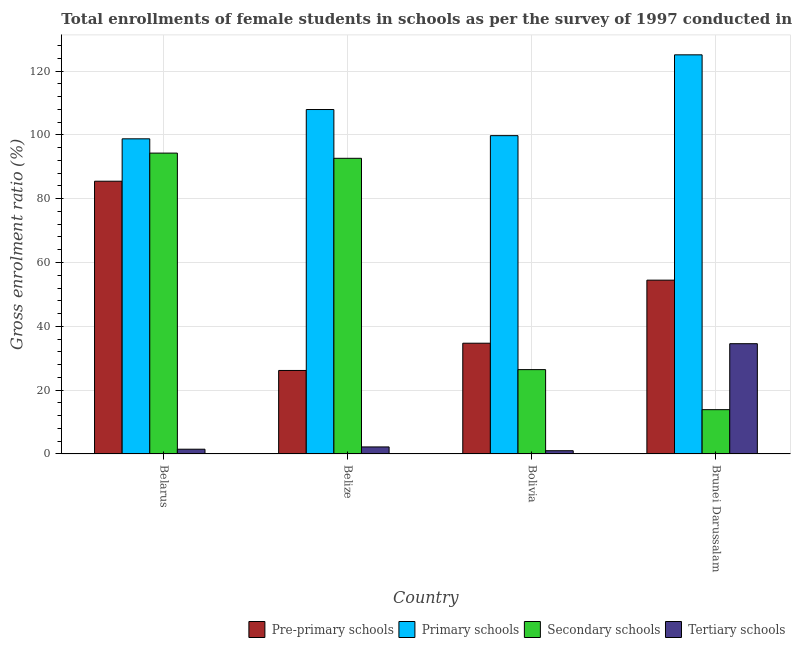How many groups of bars are there?
Give a very brief answer. 4. Are the number of bars per tick equal to the number of legend labels?
Provide a succinct answer. Yes. How many bars are there on the 4th tick from the left?
Offer a very short reply. 4. How many bars are there on the 4th tick from the right?
Give a very brief answer. 4. What is the label of the 2nd group of bars from the left?
Provide a succinct answer. Belize. What is the gross enrolment ratio(female) in primary schools in Belarus?
Offer a very short reply. 98.76. Across all countries, what is the maximum gross enrolment ratio(female) in tertiary schools?
Offer a very short reply. 34.56. Across all countries, what is the minimum gross enrolment ratio(female) in secondary schools?
Ensure brevity in your answer.  13.88. In which country was the gross enrolment ratio(female) in pre-primary schools maximum?
Offer a very short reply. Belarus. In which country was the gross enrolment ratio(female) in pre-primary schools minimum?
Your answer should be very brief. Belize. What is the total gross enrolment ratio(female) in pre-primary schools in the graph?
Make the answer very short. 200.83. What is the difference between the gross enrolment ratio(female) in pre-primary schools in Belize and that in Bolivia?
Give a very brief answer. -8.54. What is the difference between the gross enrolment ratio(female) in tertiary schools in Bolivia and the gross enrolment ratio(female) in primary schools in Belarus?
Offer a terse response. -97.74. What is the average gross enrolment ratio(female) in tertiary schools per country?
Your answer should be very brief. 9.82. What is the difference between the gross enrolment ratio(female) in primary schools and gross enrolment ratio(female) in secondary schools in Brunei Darussalam?
Keep it short and to the point. 111.19. In how many countries, is the gross enrolment ratio(female) in secondary schools greater than 48 %?
Provide a short and direct response. 2. What is the ratio of the gross enrolment ratio(female) in tertiary schools in Bolivia to that in Brunei Darussalam?
Make the answer very short. 0.03. Is the gross enrolment ratio(female) in primary schools in Belarus less than that in Belize?
Make the answer very short. Yes. What is the difference between the highest and the second highest gross enrolment ratio(female) in secondary schools?
Your answer should be compact. 1.63. What is the difference between the highest and the lowest gross enrolment ratio(female) in secondary schools?
Offer a terse response. 80.4. Is the sum of the gross enrolment ratio(female) in secondary schools in Belarus and Belize greater than the maximum gross enrolment ratio(female) in tertiary schools across all countries?
Provide a succinct answer. Yes. What does the 4th bar from the left in Brunei Darussalam represents?
Your answer should be very brief. Tertiary schools. What does the 3rd bar from the right in Belize represents?
Provide a succinct answer. Primary schools. Is it the case that in every country, the sum of the gross enrolment ratio(female) in pre-primary schools and gross enrolment ratio(female) in primary schools is greater than the gross enrolment ratio(female) in secondary schools?
Give a very brief answer. Yes. Are all the bars in the graph horizontal?
Your response must be concise. No. How many countries are there in the graph?
Your response must be concise. 4. What is the difference between two consecutive major ticks on the Y-axis?
Keep it short and to the point. 20. Does the graph contain any zero values?
Keep it short and to the point. No. How many legend labels are there?
Make the answer very short. 4. How are the legend labels stacked?
Your answer should be very brief. Horizontal. What is the title of the graph?
Make the answer very short. Total enrollments of female students in schools as per the survey of 1997 conducted in different countries. Does "Minerals" appear as one of the legend labels in the graph?
Provide a short and direct response. No. What is the label or title of the X-axis?
Your response must be concise. Country. What is the Gross enrolment ratio (%) in Pre-primary schools in Belarus?
Make the answer very short. 85.48. What is the Gross enrolment ratio (%) of Primary schools in Belarus?
Provide a short and direct response. 98.76. What is the Gross enrolment ratio (%) in Secondary schools in Belarus?
Your answer should be compact. 94.28. What is the Gross enrolment ratio (%) in Tertiary schools in Belarus?
Keep it short and to the point. 1.49. What is the Gross enrolment ratio (%) of Pre-primary schools in Belize?
Provide a short and direct response. 26.17. What is the Gross enrolment ratio (%) in Primary schools in Belize?
Ensure brevity in your answer.  107.94. What is the Gross enrolment ratio (%) of Secondary schools in Belize?
Give a very brief answer. 92.65. What is the Gross enrolment ratio (%) in Tertiary schools in Belize?
Give a very brief answer. 2.2. What is the Gross enrolment ratio (%) in Pre-primary schools in Bolivia?
Offer a terse response. 34.71. What is the Gross enrolment ratio (%) of Primary schools in Bolivia?
Offer a terse response. 99.75. What is the Gross enrolment ratio (%) of Secondary schools in Bolivia?
Your answer should be very brief. 26.43. What is the Gross enrolment ratio (%) in Tertiary schools in Bolivia?
Provide a succinct answer. 1.02. What is the Gross enrolment ratio (%) in Pre-primary schools in Brunei Darussalam?
Ensure brevity in your answer.  54.47. What is the Gross enrolment ratio (%) in Primary schools in Brunei Darussalam?
Provide a succinct answer. 125.08. What is the Gross enrolment ratio (%) of Secondary schools in Brunei Darussalam?
Make the answer very short. 13.88. What is the Gross enrolment ratio (%) of Tertiary schools in Brunei Darussalam?
Your response must be concise. 34.56. Across all countries, what is the maximum Gross enrolment ratio (%) in Pre-primary schools?
Your answer should be compact. 85.48. Across all countries, what is the maximum Gross enrolment ratio (%) of Primary schools?
Your response must be concise. 125.08. Across all countries, what is the maximum Gross enrolment ratio (%) of Secondary schools?
Your answer should be compact. 94.28. Across all countries, what is the maximum Gross enrolment ratio (%) in Tertiary schools?
Provide a short and direct response. 34.56. Across all countries, what is the minimum Gross enrolment ratio (%) of Pre-primary schools?
Your answer should be compact. 26.17. Across all countries, what is the minimum Gross enrolment ratio (%) of Primary schools?
Keep it short and to the point. 98.76. Across all countries, what is the minimum Gross enrolment ratio (%) of Secondary schools?
Your answer should be compact. 13.88. Across all countries, what is the minimum Gross enrolment ratio (%) of Tertiary schools?
Offer a very short reply. 1.02. What is the total Gross enrolment ratio (%) in Pre-primary schools in the graph?
Your answer should be very brief. 200.83. What is the total Gross enrolment ratio (%) of Primary schools in the graph?
Ensure brevity in your answer.  431.53. What is the total Gross enrolment ratio (%) in Secondary schools in the graph?
Offer a very short reply. 227.25. What is the total Gross enrolment ratio (%) of Tertiary schools in the graph?
Keep it short and to the point. 39.28. What is the difference between the Gross enrolment ratio (%) of Pre-primary schools in Belarus and that in Belize?
Offer a terse response. 59.31. What is the difference between the Gross enrolment ratio (%) in Primary schools in Belarus and that in Belize?
Keep it short and to the point. -9.18. What is the difference between the Gross enrolment ratio (%) of Secondary schools in Belarus and that in Belize?
Provide a succinct answer. 1.63. What is the difference between the Gross enrolment ratio (%) in Tertiary schools in Belarus and that in Belize?
Your response must be concise. -0.71. What is the difference between the Gross enrolment ratio (%) of Pre-primary schools in Belarus and that in Bolivia?
Your response must be concise. 50.76. What is the difference between the Gross enrolment ratio (%) in Primary schools in Belarus and that in Bolivia?
Provide a succinct answer. -1. What is the difference between the Gross enrolment ratio (%) in Secondary schools in Belarus and that in Bolivia?
Your answer should be very brief. 67.85. What is the difference between the Gross enrolment ratio (%) in Tertiary schools in Belarus and that in Bolivia?
Your answer should be compact. 0.47. What is the difference between the Gross enrolment ratio (%) in Pre-primary schools in Belarus and that in Brunei Darussalam?
Ensure brevity in your answer.  31. What is the difference between the Gross enrolment ratio (%) in Primary schools in Belarus and that in Brunei Darussalam?
Ensure brevity in your answer.  -26.32. What is the difference between the Gross enrolment ratio (%) in Secondary schools in Belarus and that in Brunei Darussalam?
Give a very brief answer. 80.4. What is the difference between the Gross enrolment ratio (%) in Tertiary schools in Belarus and that in Brunei Darussalam?
Ensure brevity in your answer.  -33.06. What is the difference between the Gross enrolment ratio (%) of Pre-primary schools in Belize and that in Bolivia?
Make the answer very short. -8.54. What is the difference between the Gross enrolment ratio (%) of Primary schools in Belize and that in Bolivia?
Provide a succinct answer. 8.18. What is the difference between the Gross enrolment ratio (%) of Secondary schools in Belize and that in Bolivia?
Give a very brief answer. 66.22. What is the difference between the Gross enrolment ratio (%) in Tertiary schools in Belize and that in Bolivia?
Offer a terse response. 1.18. What is the difference between the Gross enrolment ratio (%) in Pre-primary schools in Belize and that in Brunei Darussalam?
Offer a terse response. -28.3. What is the difference between the Gross enrolment ratio (%) in Primary schools in Belize and that in Brunei Darussalam?
Provide a short and direct response. -17.14. What is the difference between the Gross enrolment ratio (%) in Secondary schools in Belize and that in Brunei Darussalam?
Keep it short and to the point. 78.77. What is the difference between the Gross enrolment ratio (%) of Tertiary schools in Belize and that in Brunei Darussalam?
Offer a very short reply. -32.35. What is the difference between the Gross enrolment ratio (%) of Pre-primary schools in Bolivia and that in Brunei Darussalam?
Your response must be concise. -19.76. What is the difference between the Gross enrolment ratio (%) in Primary schools in Bolivia and that in Brunei Darussalam?
Keep it short and to the point. -25.32. What is the difference between the Gross enrolment ratio (%) of Secondary schools in Bolivia and that in Brunei Darussalam?
Provide a succinct answer. 12.55. What is the difference between the Gross enrolment ratio (%) in Tertiary schools in Bolivia and that in Brunei Darussalam?
Provide a succinct answer. -33.54. What is the difference between the Gross enrolment ratio (%) in Pre-primary schools in Belarus and the Gross enrolment ratio (%) in Primary schools in Belize?
Provide a short and direct response. -22.46. What is the difference between the Gross enrolment ratio (%) in Pre-primary schools in Belarus and the Gross enrolment ratio (%) in Secondary schools in Belize?
Keep it short and to the point. -7.18. What is the difference between the Gross enrolment ratio (%) of Pre-primary schools in Belarus and the Gross enrolment ratio (%) of Tertiary schools in Belize?
Keep it short and to the point. 83.27. What is the difference between the Gross enrolment ratio (%) of Primary schools in Belarus and the Gross enrolment ratio (%) of Secondary schools in Belize?
Offer a terse response. 6.11. What is the difference between the Gross enrolment ratio (%) in Primary schools in Belarus and the Gross enrolment ratio (%) in Tertiary schools in Belize?
Your answer should be compact. 96.55. What is the difference between the Gross enrolment ratio (%) of Secondary schools in Belarus and the Gross enrolment ratio (%) of Tertiary schools in Belize?
Keep it short and to the point. 92.08. What is the difference between the Gross enrolment ratio (%) of Pre-primary schools in Belarus and the Gross enrolment ratio (%) of Primary schools in Bolivia?
Provide a succinct answer. -14.28. What is the difference between the Gross enrolment ratio (%) of Pre-primary schools in Belarus and the Gross enrolment ratio (%) of Secondary schools in Bolivia?
Provide a succinct answer. 59.04. What is the difference between the Gross enrolment ratio (%) of Pre-primary schools in Belarus and the Gross enrolment ratio (%) of Tertiary schools in Bolivia?
Your answer should be very brief. 84.45. What is the difference between the Gross enrolment ratio (%) of Primary schools in Belarus and the Gross enrolment ratio (%) of Secondary schools in Bolivia?
Offer a very short reply. 72.33. What is the difference between the Gross enrolment ratio (%) in Primary schools in Belarus and the Gross enrolment ratio (%) in Tertiary schools in Bolivia?
Keep it short and to the point. 97.74. What is the difference between the Gross enrolment ratio (%) of Secondary schools in Belarus and the Gross enrolment ratio (%) of Tertiary schools in Bolivia?
Ensure brevity in your answer.  93.26. What is the difference between the Gross enrolment ratio (%) in Pre-primary schools in Belarus and the Gross enrolment ratio (%) in Primary schools in Brunei Darussalam?
Offer a terse response. -39.6. What is the difference between the Gross enrolment ratio (%) in Pre-primary schools in Belarus and the Gross enrolment ratio (%) in Secondary schools in Brunei Darussalam?
Offer a very short reply. 71.59. What is the difference between the Gross enrolment ratio (%) in Pre-primary schools in Belarus and the Gross enrolment ratio (%) in Tertiary schools in Brunei Darussalam?
Make the answer very short. 50.92. What is the difference between the Gross enrolment ratio (%) of Primary schools in Belarus and the Gross enrolment ratio (%) of Secondary schools in Brunei Darussalam?
Your response must be concise. 84.87. What is the difference between the Gross enrolment ratio (%) of Primary schools in Belarus and the Gross enrolment ratio (%) of Tertiary schools in Brunei Darussalam?
Provide a succinct answer. 64.2. What is the difference between the Gross enrolment ratio (%) in Secondary schools in Belarus and the Gross enrolment ratio (%) in Tertiary schools in Brunei Darussalam?
Offer a terse response. 59.73. What is the difference between the Gross enrolment ratio (%) in Pre-primary schools in Belize and the Gross enrolment ratio (%) in Primary schools in Bolivia?
Keep it short and to the point. -73.58. What is the difference between the Gross enrolment ratio (%) of Pre-primary schools in Belize and the Gross enrolment ratio (%) of Secondary schools in Bolivia?
Your answer should be compact. -0.26. What is the difference between the Gross enrolment ratio (%) in Pre-primary schools in Belize and the Gross enrolment ratio (%) in Tertiary schools in Bolivia?
Provide a short and direct response. 25.15. What is the difference between the Gross enrolment ratio (%) in Primary schools in Belize and the Gross enrolment ratio (%) in Secondary schools in Bolivia?
Offer a very short reply. 81.51. What is the difference between the Gross enrolment ratio (%) in Primary schools in Belize and the Gross enrolment ratio (%) in Tertiary schools in Bolivia?
Your answer should be very brief. 106.92. What is the difference between the Gross enrolment ratio (%) of Secondary schools in Belize and the Gross enrolment ratio (%) of Tertiary schools in Bolivia?
Offer a terse response. 91.63. What is the difference between the Gross enrolment ratio (%) of Pre-primary schools in Belize and the Gross enrolment ratio (%) of Primary schools in Brunei Darussalam?
Your response must be concise. -98.91. What is the difference between the Gross enrolment ratio (%) in Pre-primary schools in Belize and the Gross enrolment ratio (%) in Secondary schools in Brunei Darussalam?
Your response must be concise. 12.29. What is the difference between the Gross enrolment ratio (%) of Pre-primary schools in Belize and the Gross enrolment ratio (%) of Tertiary schools in Brunei Darussalam?
Make the answer very short. -8.39. What is the difference between the Gross enrolment ratio (%) in Primary schools in Belize and the Gross enrolment ratio (%) in Secondary schools in Brunei Darussalam?
Make the answer very short. 94.05. What is the difference between the Gross enrolment ratio (%) of Primary schools in Belize and the Gross enrolment ratio (%) of Tertiary schools in Brunei Darussalam?
Offer a very short reply. 73.38. What is the difference between the Gross enrolment ratio (%) in Secondary schools in Belize and the Gross enrolment ratio (%) in Tertiary schools in Brunei Darussalam?
Your answer should be compact. 58.1. What is the difference between the Gross enrolment ratio (%) of Pre-primary schools in Bolivia and the Gross enrolment ratio (%) of Primary schools in Brunei Darussalam?
Your answer should be very brief. -90.37. What is the difference between the Gross enrolment ratio (%) in Pre-primary schools in Bolivia and the Gross enrolment ratio (%) in Secondary schools in Brunei Darussalam?
Keep it short and to the point. 20.83. What is the difference between the Gross enrolment ratio (%) of Pre-primary schools in Bolivia and the Gross enrolment ratio (%) of Tertiary schools in Brunei Darussalam?
Provide a short and direct response. 0.15. What is the difference between the Gross enrolment ratio (%) in Primary schools in Bolivia and the Gross enrolment ratio (%) in Secondary schools in Brunei Darussalam?
Provide a short and direct response. 85.87. What is the difference between the Gross enrolment ratio (%) in Primary schools in Bolivia and the Gross enrolment ratio (%) in Tertiary schools in Brunei Darussalam?
Offer a very short reply. 65.2. What is the difference between the Gross enrolment ratio (%) of Secondary schools in Bolivia and the Gross enrolment ratio (%) of Tertiary schools in Brunei Darussalam?
Provide a succinct answer. -8.13. What is the average Gross enrolment ratio (%) of Pre-primary schools per country?
Your answer should be very brief. 50.21. What is the average Gross enrolment ratio (%) in Primary schools per country?
Offer a very short reply. 107.88. What is the average Gross enrolment ratio (%) in Secondary schools per country?
Provide a short and direct response. 56.81. What is the average Gross enrolment ratio (%) in Tertiary schools per country?
Offer a terse response. 9.82. What is the difference between the Gross enrolment ratio (%) of Pre-primary schools and Gross enrolment ratio (%) of Primary schools in Belarus?
Make the answer very short. -13.28. What is the difference between the Gross enrolment ratio (%) in Pre-primary schools and Gross enrolment ratio (%) in Secondary schools in Belarus?
Your answer should be very brief. -8.81. What is the difference between the Gross enrolment ratio (%) in Pre-primary schools and Gross enrolment ratio (%) in Tertiary schools in Belarus?
Give a very brief answer. 83.98. What is the difference between the Gross enrolment ratio (%) of Primary schools and Gross enrolment ratio (%) of Secondary schools in Belarus?
Offer a very short reply. 4.47. What is the difference between the Gross enrolment ratio (%) of Primary schools and Gross enrolment ratio (%) of Tertiary schools in Belarus?
Provide a succinct answer. 97.27. What is the difference between the Gross enrolment ratio (%) of Secondary schools and Gross enrolment ratio (%) of Tertiary schools in Belarus?
Your answer should be compact. 92.79. What is the difference between the Gross enrolment ratio (%) in Pre-primary schools and Gross enrolment ratio (%) in Primary schools in Belize?
Make the answer very short. -81.77. What is the difference between the Gross enrolment ratio (%) of Pre-primary schools and Gross enrolment ratio (%) of Secondary schools in Belize?
Offer a terse response. -66.48. What is the difference between the Gross enrolment ratio (%) in Pre-primary schools and Gross enrolment ratio (%) in Tertiary schools in Belize?
Keep it short and to the point. 23.96. What is the difference between the Gross enrolment ratio (%) in Primary schools and Gross enrolment ratio (%) in Secondary schools in Belize?
Give a very brief answer. 15.28. What is the difference between the Gross enrolment ratio (%) of Primary schools and Gross enrolment ratio (%) of Tertiary schools in Belize?
Your answer should be compact. 105.73. What is the difference between the Gross enrolment ratio (%) of Secondary schools and Gross enrolment ratio (%) of Tertiary schools in Belize?
Give a very brief answer. 90.45. What is the difference between the Gross enrolment ratio (%) in Pre-primary schools and Gross enrolment ratio (%) in Primary schools in Bolivia?
Offer a very short reply. -65.04. What is the difference between the Gross enrolment ratio (%) of Pre-primary schools and Gross enrolment ratio (%) of Secondary schools in Bolivia?
Your answer should be very brief. 8.28. What is the difference between the Gross enrolment ratio (%) in Pre-primary schools and Gross enrolment ratio (%) in Tertiary schools in Bolivia?
Ensure brevity in your answer.  33.69. What is the difference between the Gross enrolment ratio (%) in Primary schools and Gross enrolment ratio (%) in Secondary schools in Bolivia?
Your answer should be compact. 73.32. What is the difference between the Gross enrolment ratio (%) of Primary schools and Gross enrolment ratio (%) of Tertiary schools in Bolivia?
Provide a short and direct response. 98.73. What is the difference between the Gross enrolment ratio (%) in Secondary schools and Gross enrolment ratio (%) in Tertiary schools in Bolivia?
Your answer should be compact. 25.41. What is the difference between the Gross enrolment ratio (%) in Pre-primary schools and Gross enrolment ratio (%) in Primary schools in Brunei Darussalam?
Give a very brief answer. -70.61. What is the difference between the Gross enrolment ratio (%) in Pre-primary schools and Gross enrolment ratio (%) in Secondary schools in Brunei Darussalam?
Make the answer very short. 40.59. What is the difference between the Gross enrolment ratio (%) of Pre-primary schools and Gross enrolment ratio (%) of Tertiary schools in Brunei Darussalam?
Provide a succinct answer. 19.91. What is the difference between the Gross enrolment ratio (%) of Primary schools and Gross enrolment ratio (%) of Secondary schools in Brunei Darussalam?
Your response must be concise. 111.19. What is the difference between the Gross enrolment ratio (%) in Primary schools and Gross enrolment ratio (%) in Tertiary schools in Brunei Darussalam?
Ensure brevity in your answer.  90.52. What is the difference between the Gross enrolment ratio (%) in Secondary schools and Gross enrolment ratio (%) in Tertiary schools in Brunei Darussalam?
Provide a short and direct response. -20.67. What is the ratio of the Gross enrolment ratio (%) in Pre-primary schools in Belarus to that in Belize?
Give a very brief answer. 3.27. What is the ratio of the Gross enrolment ratio (%) of Primary schools in Belarus to that in Belize?
Ensure brevity in your answer.  0.92. What is the ratio of the Gross enrolment ratio (%) of Secondary schools in Belarus to that in Belize?
Keep it short and to the point. 1.02. What is the ratio of the Gross enrolment ratio (%) of Tertiary schools in Belarus to that in Belize?
Your answer should be very brief. 0.68. What is the ratio of the Gross enrolment ratio (%) of Pre-primary schools in Belarus to that in Bolivia?
Offer a terse response. 2.46. What is the ratio of the Gross enrolment ratio (%) in Primary schools in Belarus to that in Bolivia?
Offer a terse response. 0.99. What is the ratio of the Gross enrolment ratio (%) in Secondary schools in Belarus to that in Bolivia?
Your answer should be very brief. 3.57. What is the ratio of the Gross enrolment ratio (%) of Tertiary schools in Belarus to that in Bolivia?
Make the answer very short. 1.46. What is the ratio of the Gross enrolment ratio (%) of Pre-primary schools in Belarus to that in Brunei Darussalam?
Ensure brevity in your answer.  1.57. What is the ratio of the Gross enrolment ratio (%) in Primary schools in Belarus to that in Brunei Darussalam?
Your answer should be compact. 0.79. What is the ratio of the Gross enrolment ratio (%) of Secondary schools in Belarus to that in Brunei Darussalam?
Your answer should be very brief. 6.79. What is the ratio of the Gross enrolment ratio (%) in Tertiary schools in Belarus to that in Brunei Darussalam?
Your answer should be very brief. 0.04. What is the ratio of the Gross enrolment ratio (%) of Pre-primary schools in Belize to that in Bolivia?
Give a very brief answer. 0.75. What is the ratio of the Gross enrolment ratio (%) in Primary schools in Belize to that in Bolivia?
Your answer should be compact. 1.08. What is the ratio of the Gross enrolment ratio (%) in Secondary schools in Belize to that in Bolivia?
Keep it short and to the point. 3.51. What is the ratio of the Gross enrolment ratio (%) of Tertiary schools in Belize to that in Bolivia?
Your response must be concise. 2.16. What is the ratio of the Gross enrolment ratio (%) in Pre-primary schools in Belize to that in Brunei Darussalam?
Make the answer very short. 0.48. What is the ratio of the Gross enrolment ratio (%) in Primary schools in Belize to that in Brunei Darussalam?
Offer a terse response. 0.86. What is the ratio of the Gross enrolment ratio (%) in Secondary schools in Belize to that in Brunei Darussalam?
Your answer should be compact. 6.67. What is the ratio of the Gross enrolment ratio (%) in Tertiary schools in Belize to that in Brunei Darussalam?
Your response must be concise. 0.06. What is the ratio of the Gross enrolment ratio (%) in Pre-primary schools in Bolivia to that in Brunei Darussalam?
Provide a short and direct response. 0.64. What is the ratio of the Gross enrolment ratio (%) of Primary schools in Bolivia to that in Brunei Darussalam?
Give a very brief answer. 0.8. What is the ratio of the Gross enrolment ratio (%) of Secondary schools in Bolivia to that in Brunei Darussalam?
Make the answer very short. 1.9. What is the ratio of the Gross enrolment ratio (%) in Tertiary schools in Bolivia to that in Brunei Darussalam?
Offer a very short reply. 0.03. What is the difference between the highest and the second highest Gross enrolment ratio (%) in Pre-primary schools?
Offer a very short reply. 31. What is the difference between the highest and the second highest Gross enrolment ratio (%) of Primary schools?
Your response must be concise. 17.14. What is the difference between the highest and the second highest Gross enrolment ratio (%) of Secondary schools?
Make the answer very short. 1.63. What is the difference between the highest and the second highest Gross enrolment ratio (%) in Tertiary schools?
Make the answer very short. 32.35. What is the difference between the highest and the lowest Gross enrolment ratio (%) in Pre-primary schools?
Offer a terse response. 59.31. What is the difference between the highest and the lowest Gross enrolment ratio (%) of Primary schools?
Your response must be concise. 26.32. What is the difference between the highest and the lowest Gross enrolment ratio (%) in Secondary schools?
Make the answer very short. 80.4. What is the difference between the highest and the lowest Gross enrolment ratio (%) of Tertiary schools?
Give a very brief answer. 33.54. 